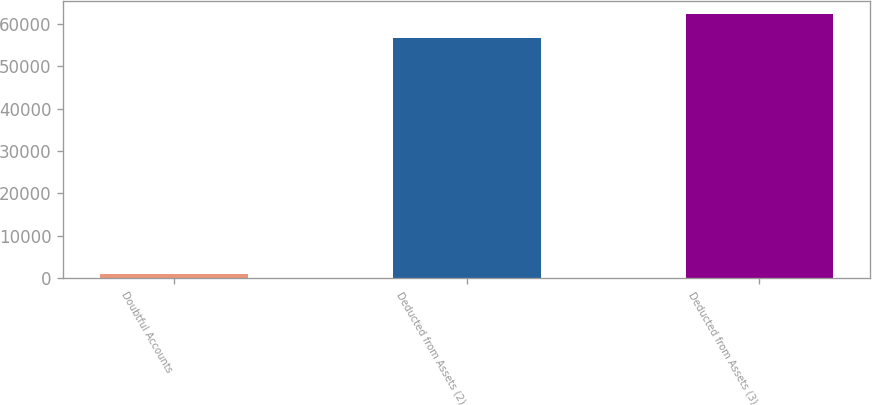Convert chart to OTSL. <chart><loc_0><loc_0><loc_500><loc_500><bar_chart><fcel>Doubtful Accounts<fcel>Deducted from Assets (2)<fcel>Deducted from Assets (3)<nl><fcel>1130<fcel>56530<fcel>62235.7<nl></chart> 